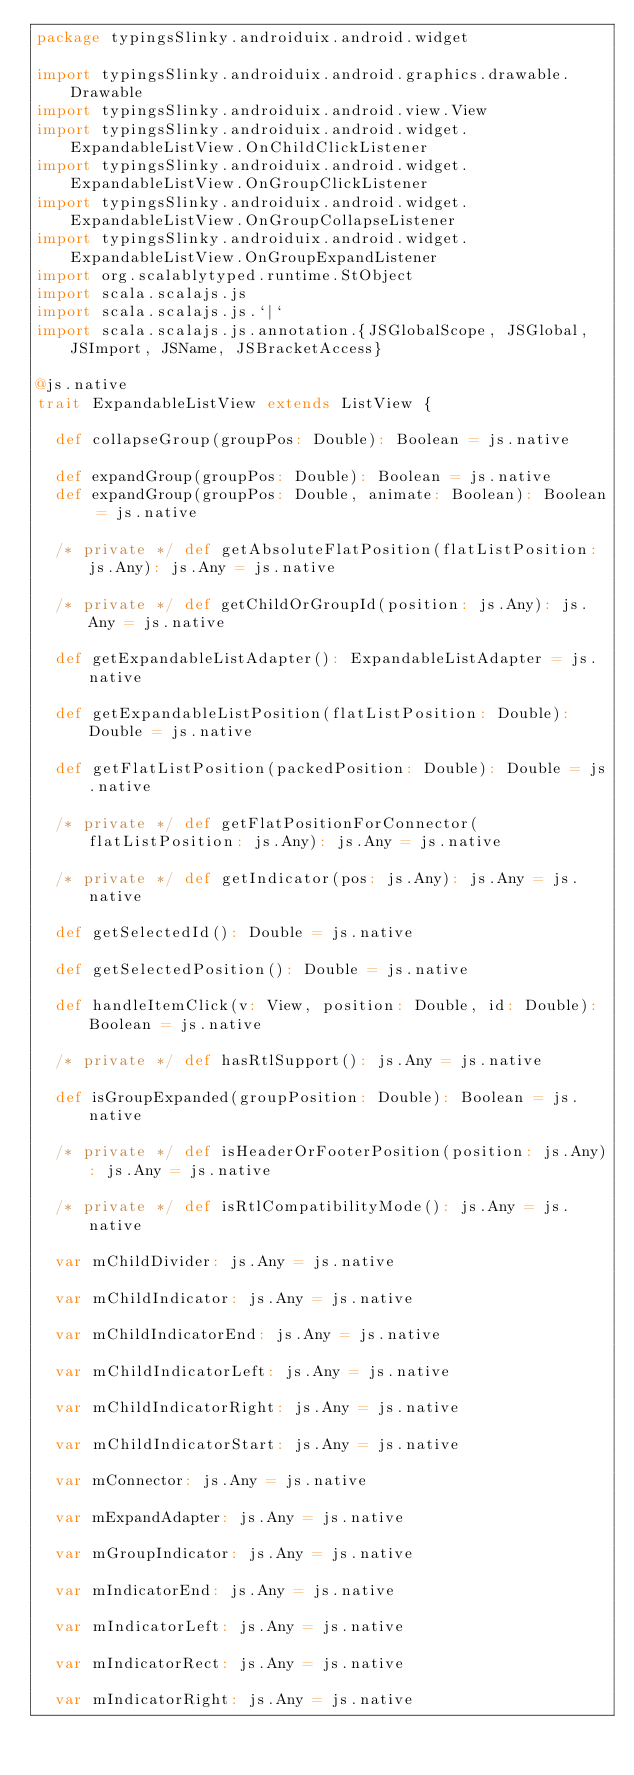Convert code to text. <code><loc_0><loc_0><loc_500><loc_500><_Scala_>package typingsSlinky.androiduix.android.widget

import typingsSlinky.androiduix.android.graphics.drawable.Drawable
import typingsSlinky.androiduix.android.view.View
import typingsSlinky.androiduix.android.widget.ExpandableListView.OnChildClickListener
import typingsSlinky.androiduix.android.widget.ExpandableListView.OnGroupClickListener
import typingsSlinky.androiduix.android.widget.ExpandableListView.OnGroupCollapseListener
import typingsSlinky.androiduix.android.widget.ExpandableListView.OnGroupExpandListener
import org.scalablytyped.runtime.StObject
import scala.scalajs.js
import scala.scalajs.js.`|`
import scala.scalajs.js.annotation.{JSGlobalScope, JSGlobal, JSImport, JSName, JSBracketAccess}

@js.native
trait ExpandableListView extends ListView {
  
  def collapseGroup(groupPos: Double): Boolean = js.native
  
  def expandGroup(groupPos: Double): Boolean = js.native
  def expandGroup(groupPos: Double, animate: Boolean): Boolean = js.native
  
  /* private */ def getAbsoluteFlatPosition(flatListPosition: js.Any): js.Any = js.native
  
  /* private */ def getChildOrGroupId(position: js.Any): js.Any = js.native
  
  def getExpandableListAdapter(): ExpandableListAdapter = js.native
  
  def getExpandableListPosition(flatListPosition: Double): Double = js.native
  
  def getFlatListPosition(packedPosition: Double): Double = js.native
  
  /* private */ def getFlatPositionForConnector(flatListPosition: js.Any): js.Any = js.native
  
  /* private */ def getIndicator(pos: js.Any): js.Any = js.native
  
  def getSelectedId(): Double = js.native
  
  def getSelectedPosition(): Double = js.native
  
  def handleItemClick(v: View, position: Double, id: Double): Boolean = js.native
  
  /* private */ def hasRtlSupport(): js.Any = js.native
  
  def isGroupExpanded(groupPosition: Double): Boolean = js.native
  
  /* private */ def isHeaderOrFooterPosition(position: js.Any): js.Any = js.native
  
  /* private */ def isRtlCompatibilityMode(): js.Any = js.native
  
  var mChildDivider: js.Any = js.native
  
  var mChildIndicator: js.Any = js.native
  
  var mChildIndicatorEnd: js.Any = js.native
  
  var mChildIndicatorLeft: js.Any = js.native
  
  var mChildIndicatorRight: js.Any = js.native
  
  var mChildIndicatorStart: js.Any = js.native
  
  var mConnector: js.Any = js.native
  
  var mExpandAdapter: js.Any = js.native
  
  var mGroupIndicator: js.Any = js.native
  
  var mIndicatorEnd: js.Any = js.native
  
  var mIndicatorLeft: js.Any = js.native
  
  var mIndicatorRect: js.Any = js.native
  
  var mIndicatorRight: js.Any = js.native
  </code> 